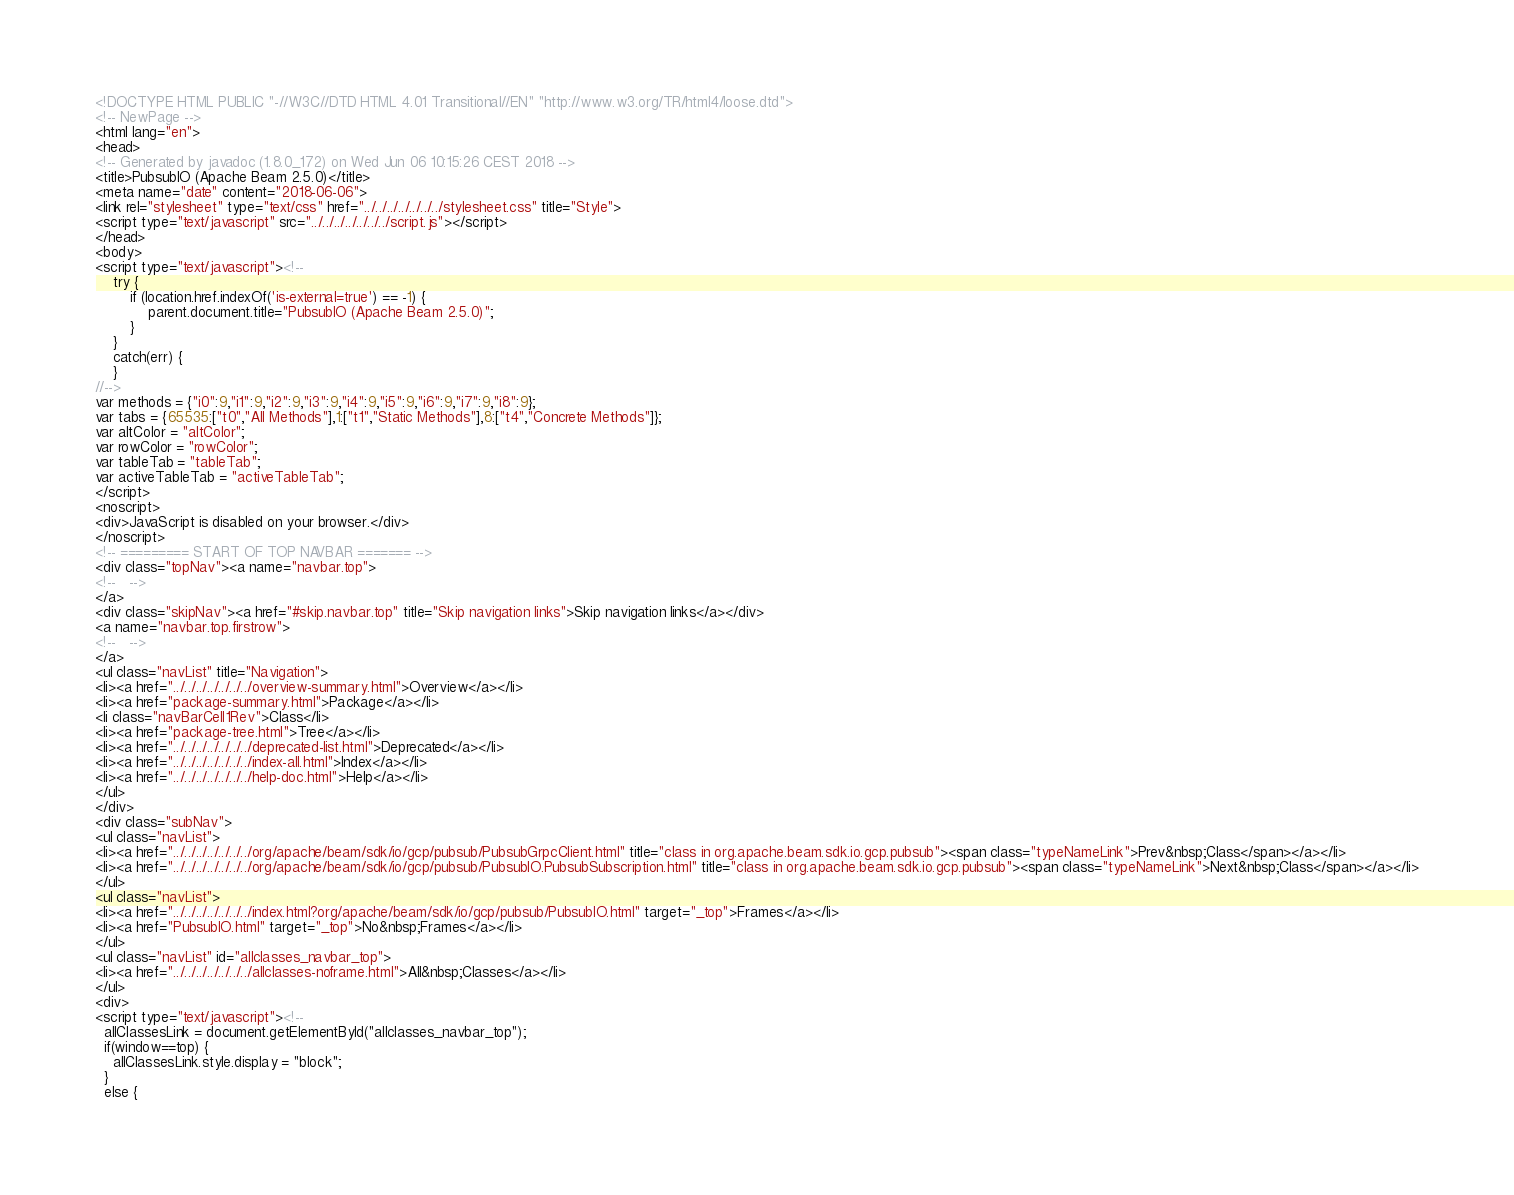Convert code to text. <code><loc_0><loc_0><loc_500><loc_500><_HTML_><!DOCTYPE HTML PUBLIC "-//W3C//DTD HTML 4.01 Transitional//EN" "http://www.w3.org/TR/html4/loose.dtd">
<!-- NewPage -->
<html lang="en">
<head>
<!-- Generated by javadoc (1.8.0_172) on Wed Jun 06 10:15:26 CEST 2018 -->
<title>PubsubIO (Apache Beam 2.5.0)</title>
<meta name="date" content="2018-06-06">
<link rel="stylesheet" type="text/css" href="../../../../../../../stylesheet.css" title="Style">
<script type="text/javascript" src="../../../../../../../script.js"></script>
</head>
<body>
<script type="text/javascript"><!--
    try {
        if (location.href.indexOf('is-external=true') == -1) {
            parent.document.title="PubsubIO (Apache Beam 2.5.0)";
        }
    }
    catch(err) {
    }
//-->
var methods = {"i0":9,"i1":9,"i2":9,"i3":9,"i4":9,"i5":9,"i6":9,"i7":9,"i8":9};
var tabs = {65535:["t0","All Methods"],1:["t1","Static Methods"],8:["t4","Concrete Methods"]};
var altColor = "altColor";
var rowColor = "rowColor";
var tableTab = "tableTab";
var activeTableTab = "activeTableTab";
</script>
<noscript>
<div>JavaScript is disabled on your browser.</div>
</noscript>
<!-- ========= START OF TOP NAVBAR ======= -->
<div class="topNav"><a name="navbar.top">
<!--   -->
</a>
<div class="skipNav"><a href="#skip.navbar.top" title="Skip navigation links">Skip navigation links</a></div>
<a name="navbar.top.firstrow">
<!--   -->
</a>
<ul class="navList" title="Navigation">
<li><a href="../../../../../../../overview-summary.html">Overview</a></li>
<li><a href="package-summary.html">Package</a></li>
<li class="navBarCell1Rev">Class</li>
<li><a href="package-tree.html">Tree</a></li>
<li><a href="../../../../../../../deprecated-list.html">Deprecated</a></li>
<li><a href="../../../../../../../index-all.html">Index</a></li>
<li><a href="../../../../../../../help-doc.html">Help</a></li>
</ul>
</div>
<div class="subNav">
<ul class="navList">
<li><a href="../../../../../../../org/apache/beam/sdk/io/gcp/pubsub/PubsubGrpcClient.html" title="class in org.apache.beam.sdk.io.gcp.pubsub"><span class="typeNameLink">Prev&nbsp;Class</span></a></li>
<li><a href="../../../../../../../org/apache/beam/sdk/io/gcp/pubsub/PubsubIO.PubsubSubscription.html" title="class in org.apache.beam.sdk.io.gcp.pubsub"><span class="typeNameLink">Next&nbsp;Class</span></a></li>
</ul>
<ul class="navList">
<li><a href="../../../../../../../index.html?org/apache/beam/sdk/io/gcp/pubsub/PubsubIO.html" target="_top">Frames</a></li>
<li><a href="PubsubIO.html" target="_top">No&nbsp;Frames</a></li>
</ul>
<ul class="navList" id="allclasses_navbar_top">
<li><a href="../../../../../../../allclasses-noframe.html">All&nbsp;Classes</a></li>
</ul>
<div>
<script type="text/javascript"><!--
  allClassesLink = document.getElementById("allclasses_navbar_top");
  if(window==top) {
    allClassesLink.style.display = "block";
  }
  else {</code> 